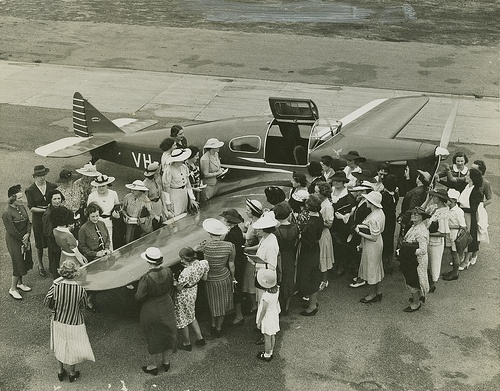Describe the objects in this image and their specific colors. I can see airplane in beige, darkgray, gray, and black tones, people in beige, black, and gray tones, people in beige, darkgray, gray, lightgray, and black tones, people in beige, gray, black, and lightgray tones, and people in beige, black, gray, darkgreen, and darkgray tones in this image. 